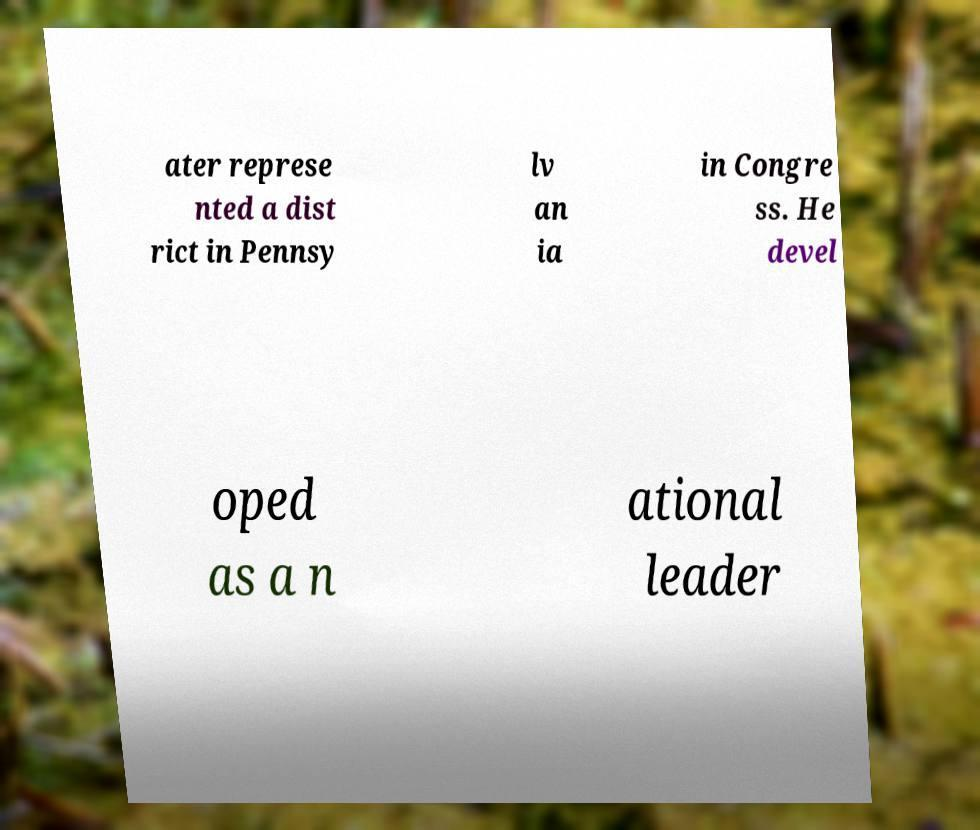Could you assist in decoding the text presented in this image and type it out clearly? ater represe nted a dist rict in Pennsy lv an ia in Congre ss. He devel oped as a n ational leader 